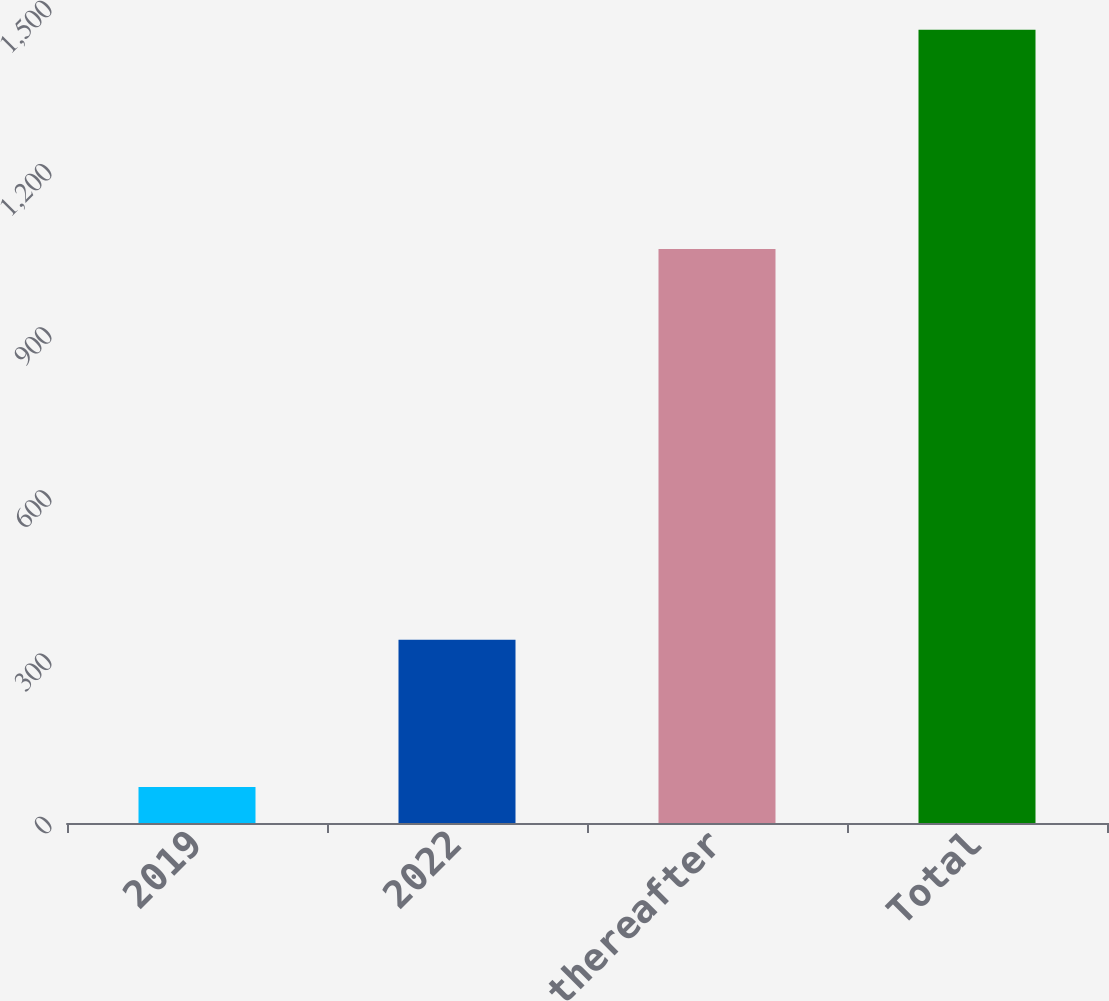Convert chart. <chart><loc_0><loc_0><loc_500><loc_500><bar_chart><fcel>2019<fcel>2022<fcel>2024 and thereafter<fcel>Total<nl><fcel>66<fcel>337<fcel>1055<fcel>1458<nl></chart> 